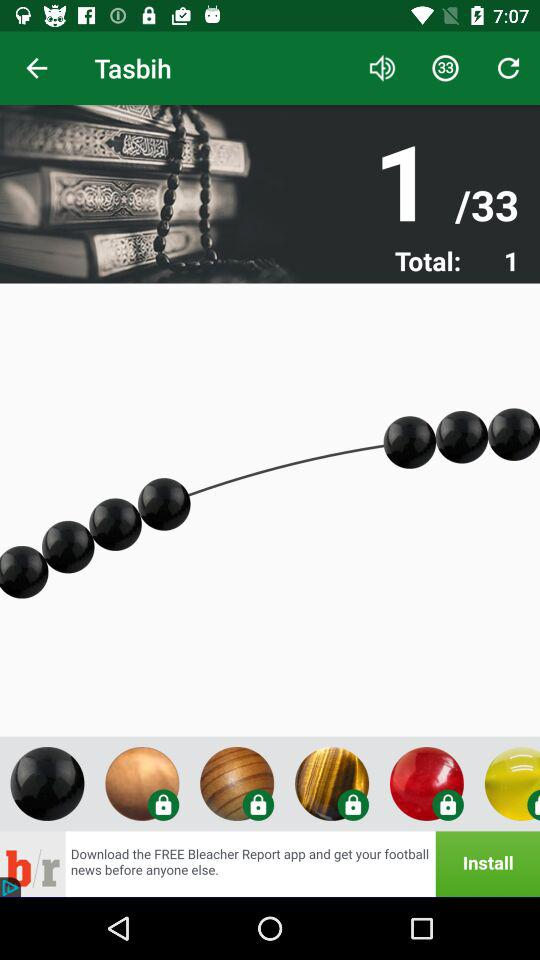How many Tasbih are there in total? There are 33 Tasbih in total. 